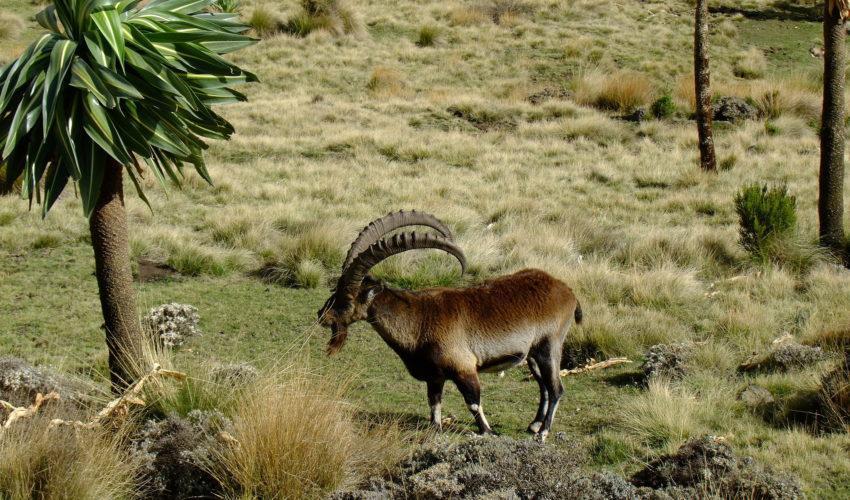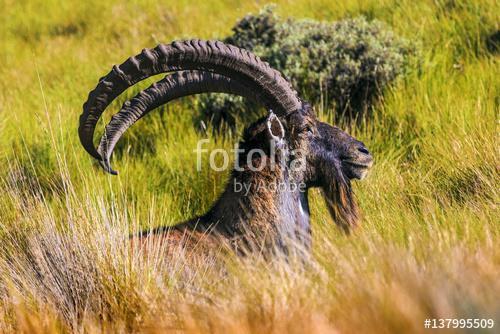The first image is the image on the left, the second image is the image on the right. Examine the images to the left and right. Is the description "Each image depicts one horned animal, and the horned animals in the left and right images face the same direction." accurate? Answer yes or no. No. The first image is the image on the left, the second image is the image on the right. Given the left and right images, does the statement "The left and right image contains the same number of goats standing in opposite directions." hold true? Answer yes or no. Yes. 